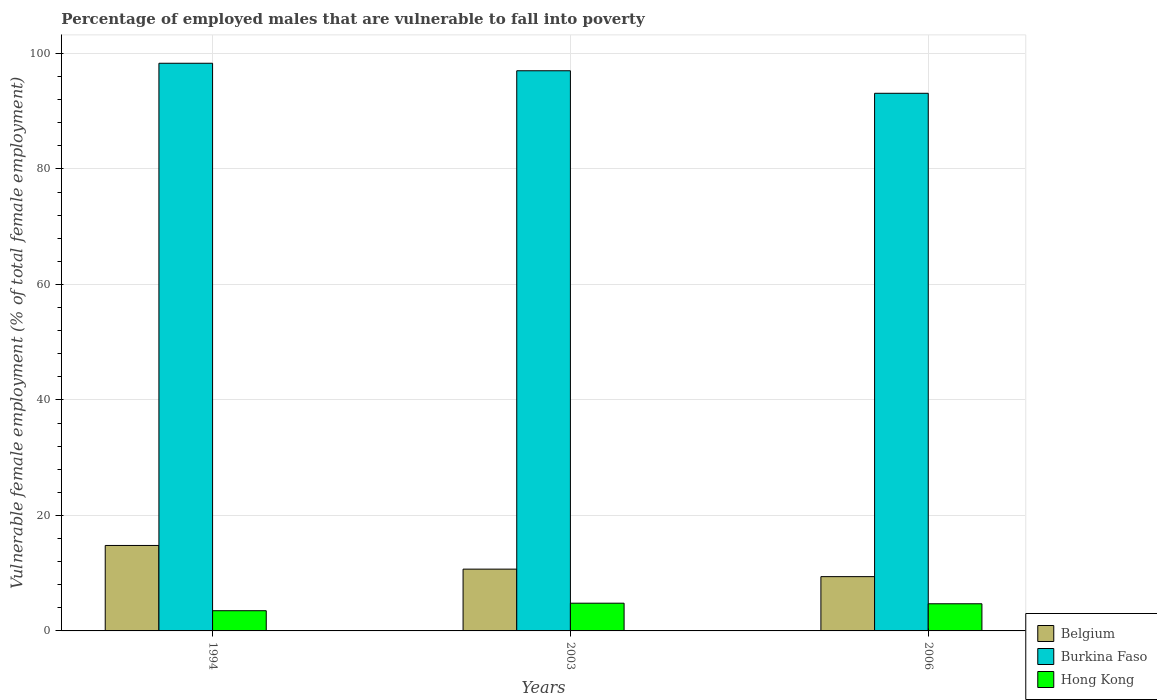How many different coloured bars are there?
Ensure brevity in your answer.  3. How many groups of bars are there?
Give a very brief answer. 3. How many bars are there on the 3rd tick from the left?
Give a very brief answer. 3. What is the percentage of employed males who are vulnerable to fall into poverty in Belgium in 2006?
Your answer should be compact. 9.4. Across all years, what is the maximum percentage of employed males who are vulnerable to fall into poverty in Burkina Faso?
Offer a terse response. 98.3. Across all years, what is the minimum percentage of employed males who are vulnerable to fall into poverty in Burkina Faso?
Offer a very short reply. 93.1. In which year was the percentage of employed males who are vulnerable to fall into poverty in Belgium maximum?
Provide a succinct answer. 1994. In which year was the percentage of employed males who are vulnerable to fall into poverty in Hong Kong minimum?
Your answer should be compact. 1994. What is the total percentage of employed males who are vulnerable to fall into poverty in Burkina Faso in the graph?
Offer a very short reply. 288.4. What is the difference between the percentage of employed males who are vulnerable to fall into poverty in Belgium in 1994 and that in 2006?
Give a very brief answer. 5.4. What is the difference between the percentage of employed males who are vulnerable to fall into poverty in Hong Kong in 2003 and the percentage of employed males who are vulnerable to fall into poverty in Burkina Faso in 2006?
Offer a terse response. -88.3. What is the average percentage of employed males who are vulnerable to fall into poverty in Belgium per year?
Ensure brevity in your answer.  11.63. In the year 1994, what is the difference between the percentage of employed males who are vulnerable to fall into poverty in Burkina Faso and percentage of employed males who are vulnerable to fall into poverty in Hong Kong?
Provide a short and direct response. 94.8. What is the ratio of the percentage of employed males who are vulnerable to fall into poverty in Hong Kong in 1994 to that in 2006?
Your response must be concise. 0.74. Is the difference between the percentage of employed males who are vulnerable to fall into poverty in Burkina Faso in 1994 and 2003 greater than the difference between the percentage of employed males who are vulnerable to fall into poverty in Hong Kong in 1994 and 2003?
Provide a short and direct response. Yes. What is the difference between the highest and the second highest percentage of employed males who are vulnerable to fall into poverty in Hong Kong?
Offer a terse response. 0.1. What is the difference between the highest and the lowest percentage of employed males who are vulnerable to fall into poverty in Burkina Faso?
Give a very brief answer. 5.2. What does the 3rd bar from the left in 2006 represents?
Provide a short and direct response. Hong Kong. What does the 1st bar from the right in 1994 represents?
Give a very brief answer. Hong Kong. Is it the case that in every year, the sum of the percentage of employed males who are vulnerable to fall into poverty in Belgium and percentage of employed males who are vulnerable to fall into poverty in Burkina Faso is greater than the percentage of employed males who are vulnerable to fall into poverty in Hong Kong?
Your response must be concise. Yes. How many years are there in the graph?
Your answer should be very brief. 3. What is the difference between two consecutive major ticks on the Y-axis?
Give a very brief answer. 20. How many legend labels are there?
Ensure brevity in your answer.  3. What is the title of the graph?
Your answer should be very brief. Percentage of employed males that are vulnerable to fall into poverty. What is the label or title of the X-axis?
Offer a terse response. Years. What is the label or title of the Y-axis?
Provide a short and direct response. Vulnerable female employment (% of total female employment). What is the Vulnerable female employment (% of total female employment) of Belgium in 1994?
Give a very brief answer. 14.8. What is the Vulnerable female employment (% of total female employment) of Burkina Faso in 1994?
Provide a short and direct response. 98.3. What is the Vulnerable female employment (% of total female employment) in Belgium in 2003?
Give a very brief answer. 10.7. What is the Vulnerable female employment (% of total female employment) in Burkina Faso in 2003?
Provide a succinct answer. 97. What is the Vulnerable female employment (% of total female employment) of Hong Kong in 2003?
Offer a very short reply. 4.8. What is the Vulnerable female employment (% of total female employment) in Belgium in 2006?
Your answer should be compact. 9.4. What is the Vulnerable female employment (% of total female employment) of Burkina Faso in 2006?
Give a very brief answer. 93.1. What is the Vulnerable female employment (% of total female employment) of Hong Kong in 2006?
Give a very brief answer. 4.7. Across all years, what is the maximum Vulnerable female employment (% of total female employment) in Belgium?
Offer a very short reply. 14.8. Across all years, what is the maximum Vulnerable female employment (% of total female employment) of Burkina Faso?
Provide a succinct answer. 98.3. Across all years, what is the maximum Vulnerable female employment (% of total female employment) of Hong Kong?
Ensure brevity in your answer.  4.8. Across all years, what is the minimum Vulnerable female employment (% of total female employment) of Belgium?
Your answer should be very brief. 9.4. Across all years, what is the minimum Vulnerable female employment (% of total female employment) in Burkina Faso?
Your response must be concise. 93.1. What is the total Vulnerable female employment (% of total female employment) of Belgium in the graph?
Provide a short and direct response. 34.9. What is the total Vulnerable female employment (% of total female employment) in Burkina Faso in the graph?
Provide a short and direct response. 288.4. What is the total Vulnerable female employment (% of total female employment) of Hong Kong in the graph?
Keep it short and to the point. 13. What is the difference between the Vulnerable female employment (% of total female employment) in Burkina Faso in 1994 and that in 2003?
Give a very brief answer. 1.3. What is the difference between the Vulnerable female employment (% of total female employment) in Belgium in 1994 and that in 2006?
Give a very brief answer. 5.4. What is the difference between the Vulnerable female employment (% of total female employment) in Burkina Faso in 1994 and that in 2006?
Your answer should be very brief. 5.2. What is the difference between the Vulnerable female employment (% of total female employment) in Burkina Faso in 2003 and that in 2006?
Give a very brief answer. 3.9. What is the difference between the Vulnerable female employment (% of total female employment) of Hong Kong in 2003 and that in 2006?
Give a very brief answer. 0.1. What is the difference between the Vulnerable female employment (% of total female employment) of Belgium in 1994 and the Vulnerable female employment (% of total female employment) of Burkina Faso in 2003?
Provide a short and direct response. -82.2. What is the difference between the Vulnerable female employment (% of total female employment) of Burkina Faso in 1994 and the Vulnerable female employment (% of total female employment) of Hong Kong in 2003?
Provide a succinct answer. 93.5. What is the difference between the Vulnerable female employment (% of total female employment) in Belgium in 1994 and the Vulnerable female employment (% of total female employment) in Burkina Faso in 2006?
Your answer should be compact. -78.3. What is the difference between the Vulnerable female employment (% of total female employment) in Belgium in 1994 and the Vulnerable female employment (% of total female employment) in Hong Kong in 2006?
Make the answer very short. 10.1. What is the difference between the Vulnerable female employment (% of total female employment) of Burkina Faso in 1994 and the Vulnerable female employment (% of total female employment) of Hong Kong in 2006?
Your answer should be very brief. 93.6. What is the difference between the Vulnerable female employment (% of total female employment) in Belgium in 2003 and the Vulnerable female employment (% of total female employment) in Burkina Faso in 2006?
Your answer should be very brief. -82.4. What is the difference between the Vulnerable female employment (% of total female employment) of Burkina Faso in 2003 and the Vulnerable female employment (% of total female employment) of Hong Kong in 2006?
Provide a short and direct response. 92.3. What is the average Vulnerable female employment (% of total female employment) in Belgium per year?
Give a very brief answer. 11.63. What is the average Vulnerable female employment (% of total female employment) of Burkina Faso per year?
Give a very brief answer. 96.13. What is the average Vulnerable female employment (% of total female employment) in Hong Kong per year?
Keep it short and to the point. 4.33. In the year 1994, what is the difference between the Vulnerable female employment (% of total female employment) of Belgium and Vulnerable female employment (% of total female employment) of Burkina Faso?
Give a very brief answer. -83.5. In the year 1994, what is the difference between the Vulnerable female employment (% of total female employment) of Burkina Faso and Vulnerable female employment (% of total female employment) of Hong Kong?
Make the answer very short. 94.8. In the year 2003, what is the difference between the Vulnerable female employment (% of total female employment) in Belgium and Vulnerable female employment (% of total female employment) in Burkina Faso?
Your answer should be compact. -86.3. In the year 2003, what is the difference between the Vulnerable female employment (% of total female employment) of Belgium and Vulnerable female employment (% of total female employment) of Hong Kong?
Keep it short and to the point. 5.9. In the year 2003, what is the difference between the Vulnerable female employment (% of total female employment) of Burkina Faso and Vulnerable female employment (% of total female employment) of Hong Kong?
Provide a short and direct response. 92.2. In the year 2006, what is the difference between the Vulnerable female employment (% of total female employment) of Belgium and Vulnerable female employment (% of total female employment) of Burkina Faso?
Ensure brevity in your answer.  -83.7. In the year 2006, what is the difference between the Vulnerable female employment (% of total female employment) of Belgium and Vulnerable female employment (% of total female employment) of Hong Kong?
Provide a short and direct response. 4.7. In the year 2006, what is the difference between the Vulnerable female employment (% of total female employment) of Burkina Faso and Vulnerable female employment (% of total female employment) of Hong Kong?
Your response must be concise. 88.4. What is the ratio of the Vulnerable female employment (% of total female employment) in Belgium in 1994 to that in 2003?
Your answer should be compact. 1.38. What is the ratio of the Vulnerable female employment (% of total female employment) of Burkina Faso in 1994 to that in 2003?
Give a very brief answer. 1.01. What is the ratio of the Vulnerable female employment (% of total female employment) in Hong Kong in 1994 to that in 2003?
Provide a short and direct response. 0.73. What is the ratio of the Vulnerable female employment (% of total female employment) of Belgium in 1994 to that in 2006?
Provide a short and direct response. 1.57. What is the ratio of the Vulnerable female employment (% of total female employment) in Burkina Faso in 1994 to that in 2006?
Your response must be concise. 1.06. What is the ratio of the Vulnerable female employment (% of total female employment) in Hong Kong in 1994 to that in 2006?
Your answer should be very brief. 0.74. What is the ratio of the Vulnerable female employment (% of total female employment) of Belgium in 2003 to that in 2006?
Offer a terse response. 1.14. What is the ratio of the Vulnerable female employment (% of total female employment) of Burkina Faso in 2003 to that in 2006?
Your answer should be compact. 1.04. What is the ratio of the Vulnerable female employment (% of total female employment) in Hong Kong in 2003 to that in 2006?
Provide a short and direct response. 1.02. What is the difference between the highest and the second highest Vulnerable female employment (% of total female employment) in Belgium?
Your answer should be very brief. 4.1. What is the difference between the highest and the second highest Vulnerable female employment (% of total female employment) in Burkina Faso?
Make the answer very short. 1.3. What is the difference between the highest and the lowest Vulnerable female employment (% of total female employment) of Belgium?
Provide a short and direct response. 5.4. What is the difference between the highest and the lowest Vulnerable female employment (% of total female employment) in Burkina Faso?
Your answer should be compact. 5.2. 